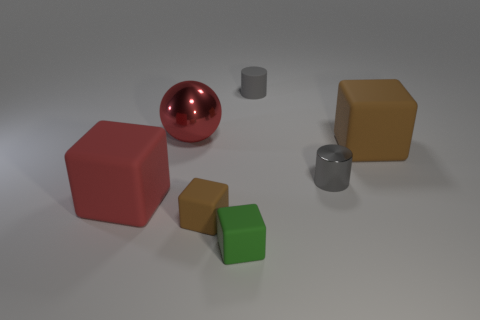Subtract all brown blocks. How many were subtracted if there are1brown blocks left? 1 Add 3 big cyan cylinders. How many objects exist? 10 Subtract all blocks. How many objects are left? 3 Add 7 gray blocks. How many gray blocks exist? 7 Subtract 2 brown cubes. How many objects are left? 5 Subtract all tiny brown blocks. Subtract all green matte objects. How many objects are left? 5 Add 7 brown blocks. How many brown blocks are left? 9 